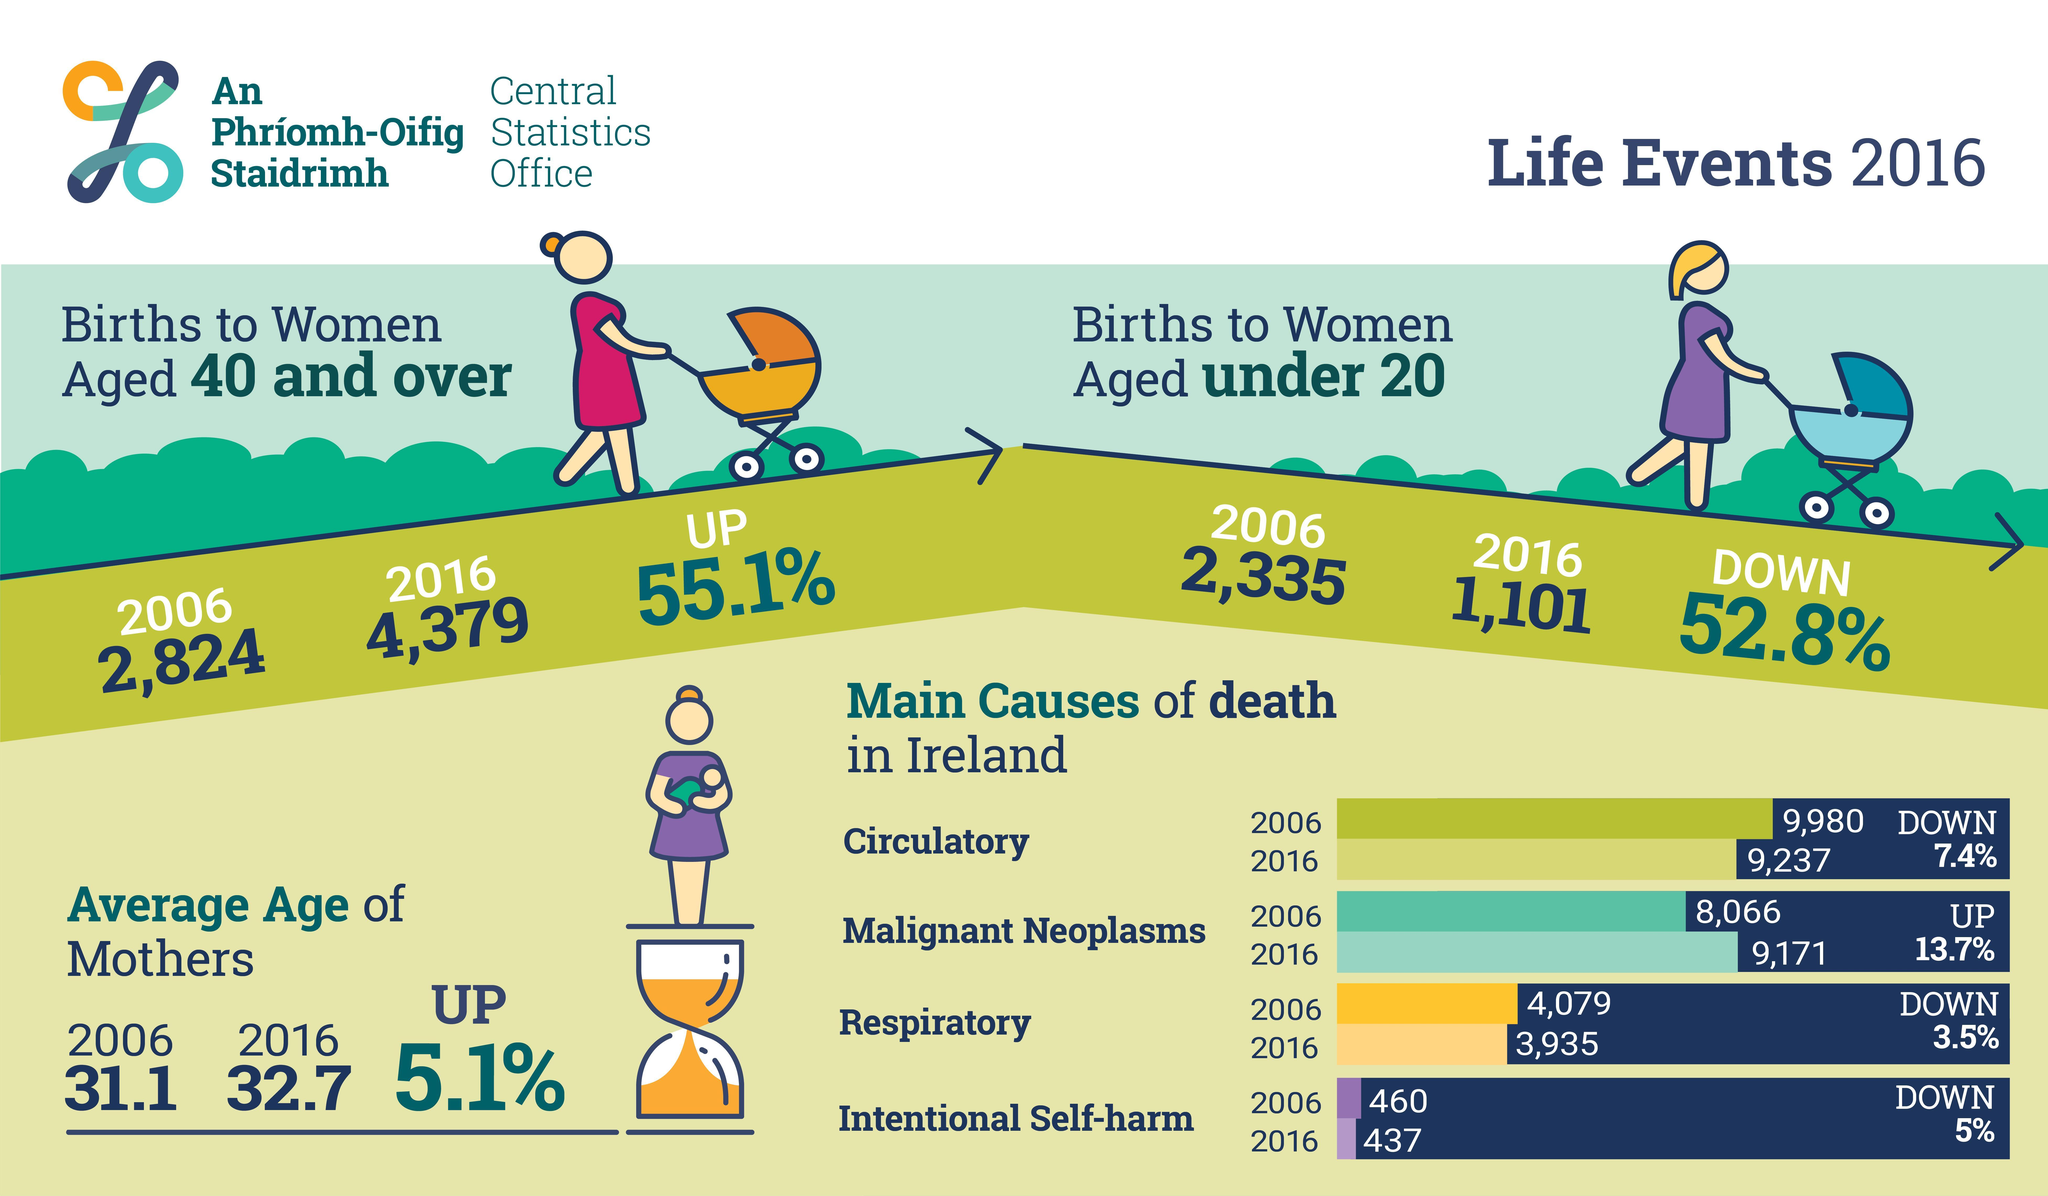What has emerged as the main cause of death in Ireland in the 2016?
Answer the question with a short phrase. Malignant Neoplasms Which cause of death has shown a significant decrease in terms of percentage in 2016? Circulatory Which age group of women have registered higher birth rates in 2016, under 20, 20 and over, or 40 and over? 40 and over Which age group of women have registered higher birth rate in 2006, under 40, under 20, 20 and over? under 20 Has the average age of mothers increased, decreased or remained the same during the period 2006-2016? increased 